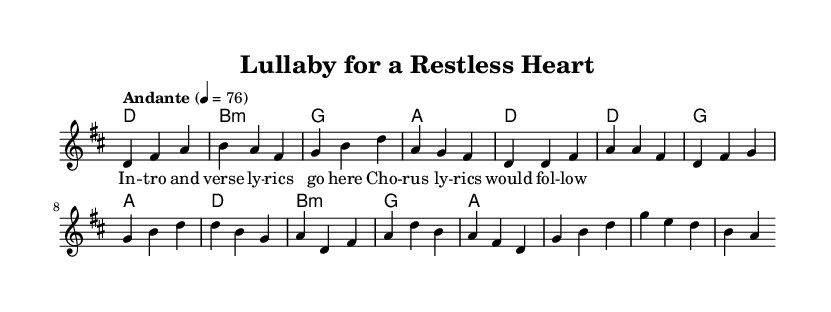What is the key signature of this music? The key signature is D major, which has two sharps: F# and C#. This can be identified from the beginning of the score, where the key signature is notated.
Answer: D major What is the time signature of this music? The time signature is 3/4, indicated at the start of the score. This means there are three beats per measure, with each beat being a quarter note.
Answer: 3/4 What is the tempo marking for this piece? The tempo marking is "Andante", which means a moderately slow tempo. This is specified at the beginning of the piece alongside a metronome marking of 76 beats per minute.
Answer: Andante How many measures are included in the provided music? By counting the number of vertical lines (bar lines) that separate the measures in the given melody and harmonies, we find that there are a total of 8 measures in the excerpt.
Answer: 8 What are the predominant musical features of Latin acoustic ballads reflected in this piece? This piece incorporates a gentle melody, a 3/4 time signature (often found in waltzes), and harmonic support that emphasizes emotional themes, typical of Latin acoustic ballads focusing on parental love and support.
Answer: Gentle melody, 3/4 time, emotional themes In which section does the melody begin to shift towards the chorus? The melody signifies a shift towards the chorus starting at the measure that contains the notes D4, F#4, A4, and D4, which is the fifth measure based on the provided excerpt structure.
Answer: Fifth measure 